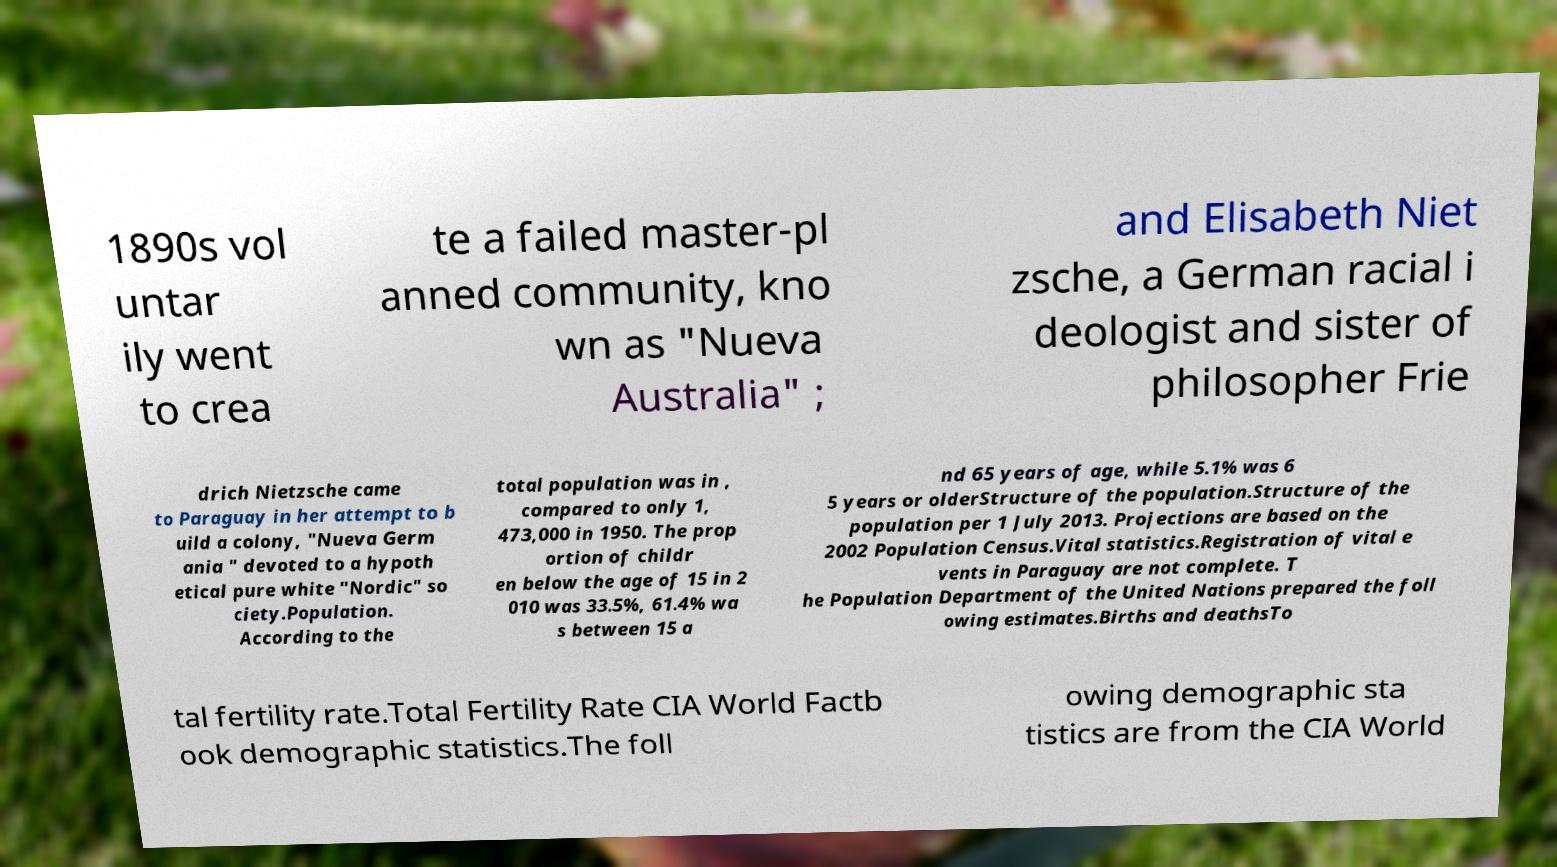I need the written content from this picture converted into text. Can you do that? 1890s vol untar ily went to crea te a failed master-pl anned community, kno wn as "Nueva Australia" ; and Elisabeth Niet zsche, a German racial i deologist and sister of philosopher Frie drich Nietzsche came to Paraguay in her attempt to b uild a colony, "Nueva Germ ania " devoted to a hypoth etical pure white "Nordic" so ciety.Population. According to the total population was in , compared to only 1, 473,000 in 1950. The prop ortion of childr en below the age of 15 in 2 010 was 33.5%, 61.4% wa s between 15 a nd 65 years of age, while 5.1% was 6 5 years or olderStructure of the population.Structure of the population per 1 July 2013. Projections are based on the 2002 Population Census.Vital statistics.Registration of vital e vents in Paraguay are not complete. T he Population Department of the United Nations prepared the foll owing estimates.Births and deathsTo tal fertility rate.Total Fertility Rate CIA World Factb ook demographic statistics.The foll owing demographic sta tistics are from the CIA World 